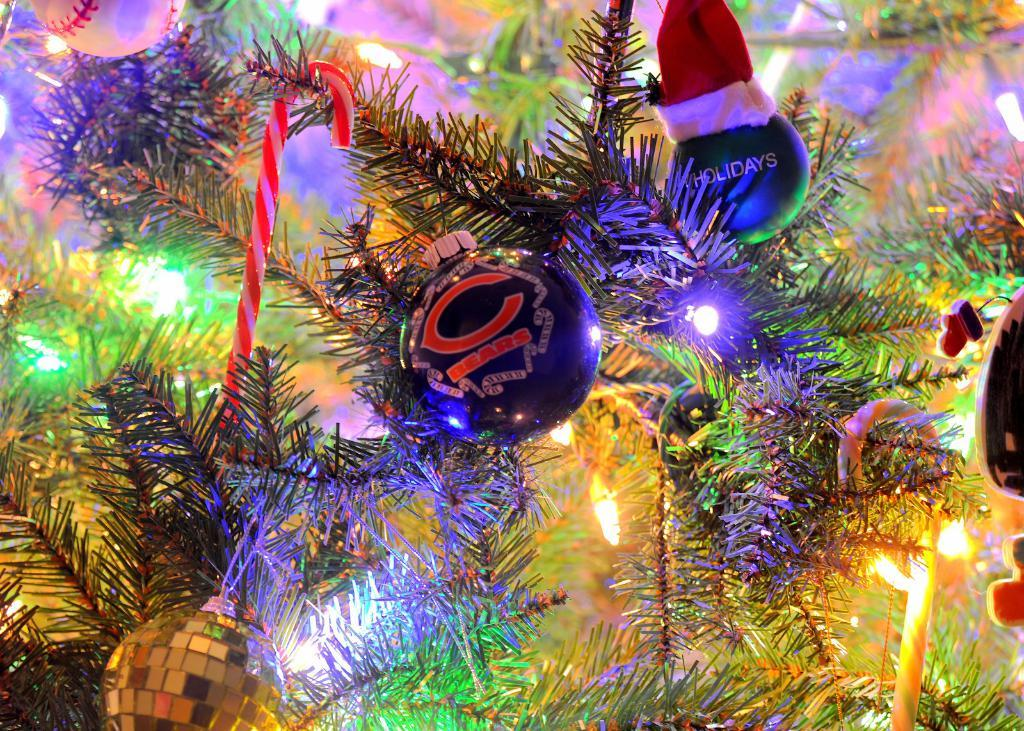What type of tree is in the image? There is a Christmas tree in the image. What decorations are on the Christmas tree? The Christmas tree has lights and balls on it. Are there any other objects on the Christmas tree? Yes, there are other objects on the Christmas tree. How many cherries are hanging from the branches of the Christmas tree in the image? There are no cherries present on the Christmas tree in the image. What is the cause of death for the person depicted in the image? There is no person depicted in the image, so it is impossible to determine the cause of death. 